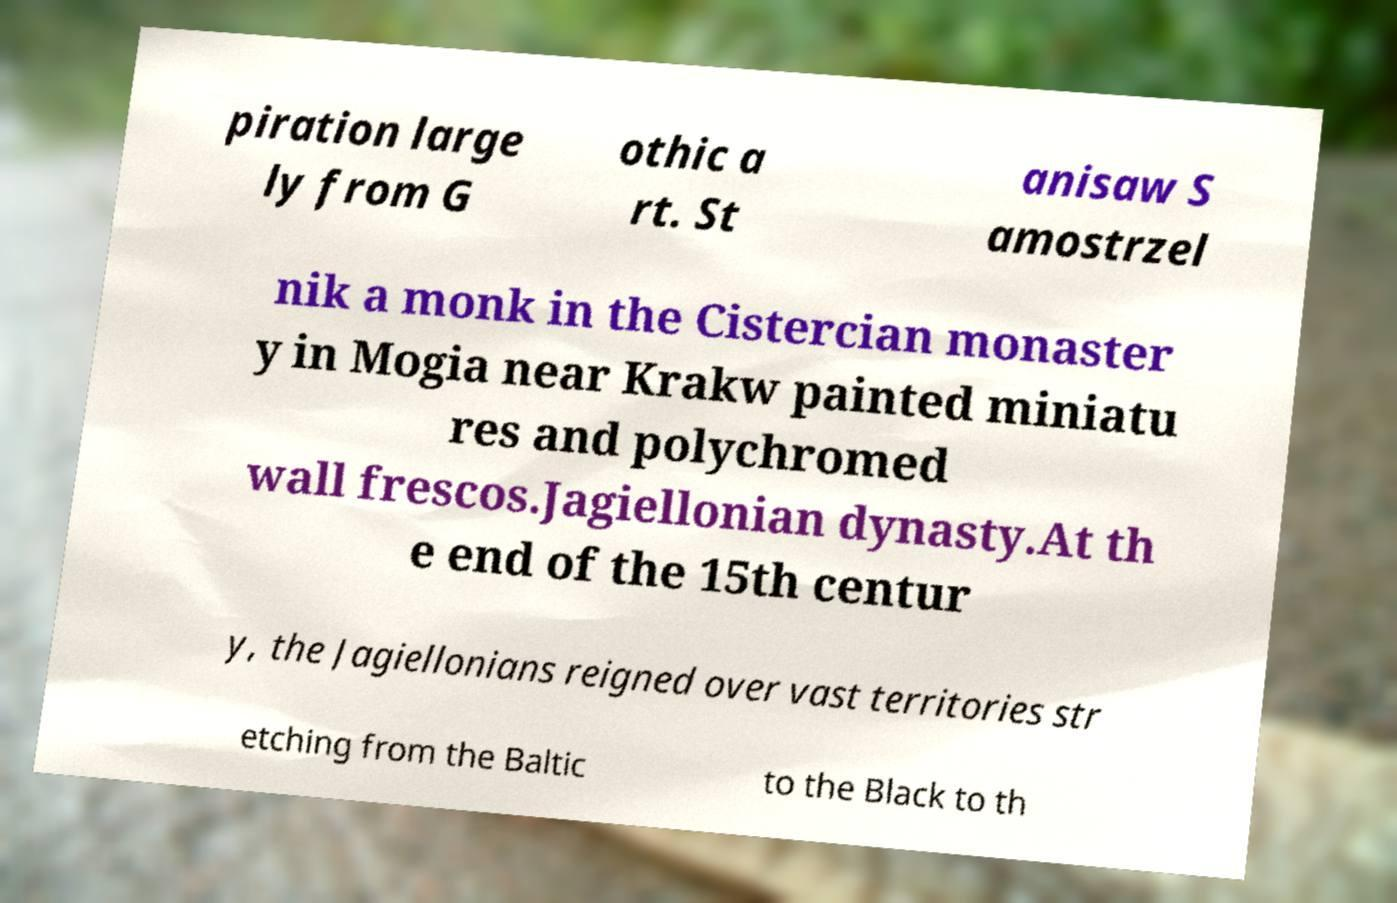For documentation purposes, I need the text within this image transcribed. Could you provide that? piration large ly from G othic a rt. St anisaw S amostrzel nik a monk in the Cistercian monaster y in Mogia near Krakw painted miniatu res and polychromed wall frescos.Jagiellonian dynasty.At th e end of the 15th centur y, the Jagiellonians reigned over vast territories str etching from the Baltic to the Black to th 